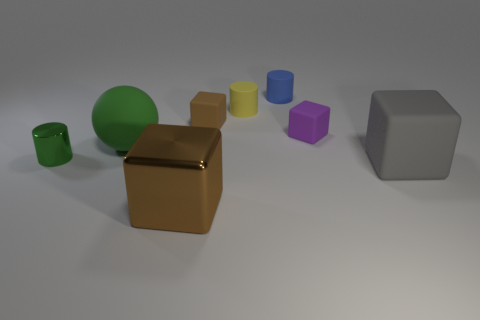There is a thing that is both behind the small shiny cylinder and to the left of the small brown block; what is its size?
Your answer should be very brief. Large. How many large gray objects are made of the same material as the small green cylinder?
Offer a very short reply. 0. How many cylinders are either purple rubber objects or brown objects?
Your answer should be compact. 0. There is a green object behind the small object on the left side of the brown block that is in front of the large rubber cube; what is its size?
Your answer should be very brief. Large. What is the color of the object that is in front of the small metallic cylinder and behind the metallic block?
Ensure brevity in your answer.  Gray. Do the blue cylinder and the matte block that is left of the blue object have the same size?
Your answer should be very brief. Yes. Is there any other thing that is the same shape as the purple object?
Keep it short and to the point. Yes. What is the color of the other metal thing that is the same shape as the blue object?
Ensure brevity in your answer.  Green. Does the brown metallic object have the same size as the brown rubber cube?
Your answer should be compact. No. How many other things are the same size as the yellow cylinder?
Your answer should be very brief. 4. 